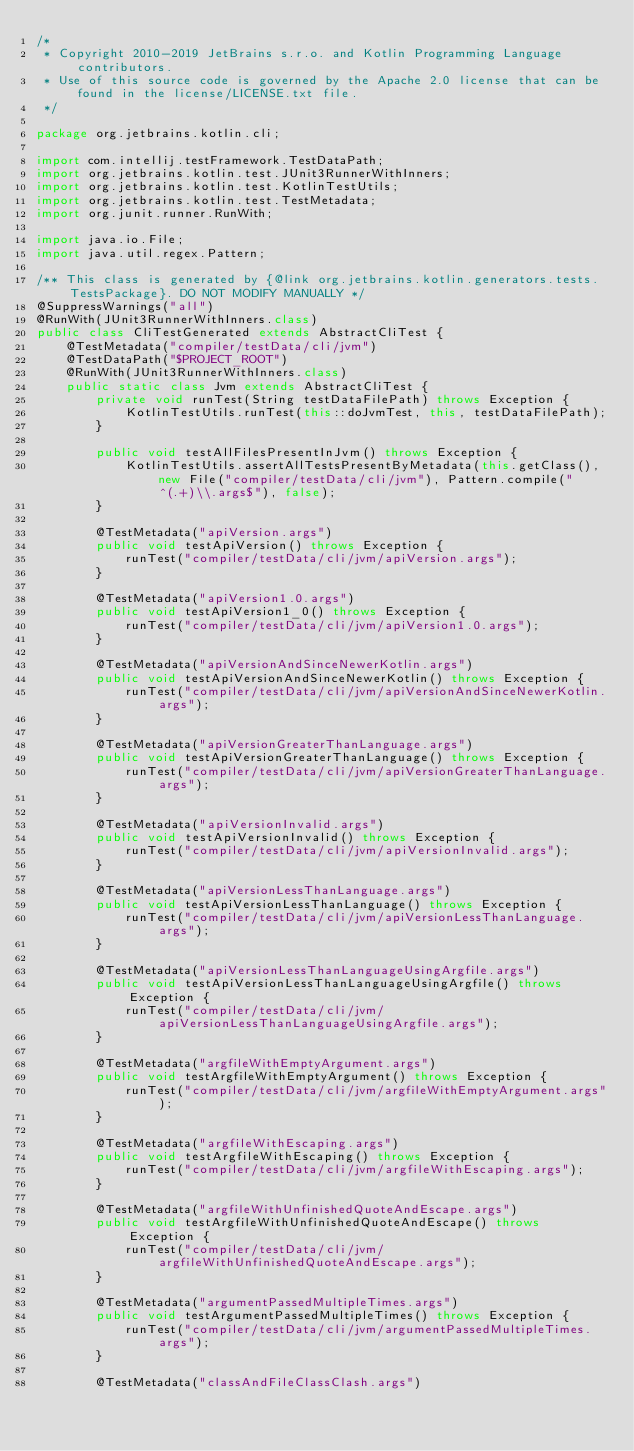<code> <loc_0><loc_0><loc_500><loc_500><_Java_>/*
 * Copyright 2010-2019 JetBrains s.r.o. and Kotlin Programming Language contributors.
 * Use of this source code is governed by the Apache 2.0 license that can be found in the license/LICENSE.txt file.
 */

package org.jetbrains.kotlin.cli;

import com.intellij.testFramework.TestDataPath;
import org.jetbrains.kotlin.test.JUnit3RunnerWithInners;
import org.jetbrains.kotlin.test.KotlinTestUtils;
import org.jetbrains.kotlin.test.TestMetadata;
import org.junit.runner.RunWith;

import java.io.File;
import java.util.regex.Pattern;

/** This class is generated by {@link org.jetbrains.kotlin.generators.tests.TestsPackage}. DO NOT MODIFY MANUALLY */
@SuppressWarnings("all")
@RunWith(JUnit3RunnerWithInners.class)
public class CliTestGenerated extends AbstractCliTest {
    @TestMetadata("compiler/testData/cli/jvm")
    @TestDataPath("$PROJECT_ROOT")
    @RunWith(JUnit3RunnerWithInners.class)
    public static class Jvm extends AbstractCliTest {
        private void runTest(String testDataFilePath) throws Exception {
            KotlinTestUtils.runTest(this::doJvmTest, this, testDataFilePath);
        }

        public void testAllFilesPresentInJvm() throws Exception {
            KotlinTestUtils.assertAllTestsPresentByMetadata(this.getClass(), new File("compiler/testData/cli/jvm"), Pattern.compile("^(.+)\\.args$"), false);
        }

        @TestMetadata("apiVersion.args")
        public void testApiVersion() throws Exception {
            runTest("compiler/testData/cli/jvm/apiVersion.args");
        }

        @TestMetadata("apiVersion1.0.args")
        public void testApiVersion1_0() throws Exception {
            runTest("compiler/testData/cli/jvm/apiVersion1.0.args");
        }

        @TestMetadata("apiVersionAndSinceNewerKotlin.args")
        public void testApiVersionAndSinceNewerKotlin() throws Exception {
            runTest("compiler/testData/cli/jvm/apiVersionAndSinceNewerKotlin.args");
        }

        @TestMetadata("apiVersionGreaterThanLanguage.args")
        public void testApiVersionGreaterThanLanguage() throws Exception {
            runTest("compiler/testData/cli/jvm/apiVersionGreaterThanLanguage.args");
        }

        @TestMetadata("apiVersionInvalid.args")
        public void testApiVersionInvalid() throws Exception {
            runTest("compiler/testData/cli/jvm/apiVersionInvalid.args");
        }

        @TestMetadata("apiVersionLessThanLanguage.args")
        public void testApiVersionLessThanLanguage() throws Exception {
            runTest("compiler/testData/cli/jvm/apiVersionLessThanLanguage.args");
        }

        @TestMetadata("apiVersionLessThanLanguageUsingArgfile.args")
        public void testApiVersionLessThanLanguageUsingArgfile() throws Exception {
            runTest("compiler/testData/cli/jvm/apiVersionLessThanLanguageUsingArgfile.args");
        }

        @TestMetadata("argfileWithEmptyArgument.args")
        public void testArgfileWithEmptyArgument() throws Exception {
            runTest("compiler/testData/cli/jvm/argfileWithEmptyArgument.args");
        }

        @TestMetadata("argfileWithEscaping.args")
        public void testArgfileWithEscaping() throws Exception {
            runTest("compiler/testData/cli/jvm/argfileWithEscaping.args");
        }

        @TestMetadata("argfileWithUnfinishedQuoteAndEscape.args")
        public void testArgfileWithUnfinishedQuoteAndEscape() throws Exception {
            runTest("compiler/testData/cli/jvm/argfileWithUnfinishedQuoteAndEscape.args");
        }

        @TestMetadata("argumentPassedMultipleTimes.args")
        public void testArgumentPassedMultipleTimes() throws Exception {
            runTest("compiler/testData/cli/jvm/argumentPassedMultipleTimes.args");
        }

        @TestMetadata("classAndFileClassClash.args")</code> 